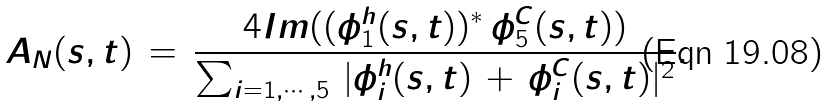Convert formula to latex. <formula><loc_0><loc_0><loc_500><loc_500>A _ { N } ( s , t ) \, = \, \frac { 4 I m ( ( \phi _ { 1 } ^ { h } ( s , t ) ) ^ { * } \, \phi _ { 5 } ^ { C } ( s , t ) ) } { \sum _ { i = 1 , \cdots , 5 } \, | \phi ^ { h } _ { i } ( s , t ) \, + \, \phi ^ { C } _ { i } ( s , t ) | ^ { 2 } } .</formula> 